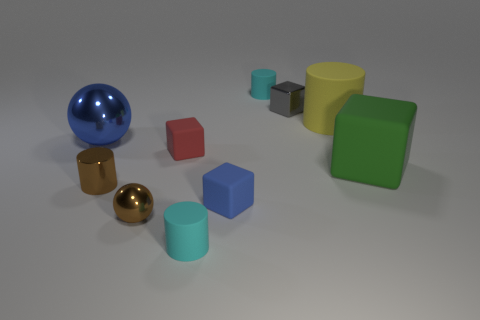Subtract all blocks. How many objects are left? 6 Subtract all tiny matte objects. Subtract all red metallic spheres. How many objects are left? 6 Add 9 large rubber cylinders. How many large rubber cylinders are left? 10 Add 5 brown metallic things. How many brown metallic things exist? 7 Subtract 0 gray cylinders. How many objects are left? 10 